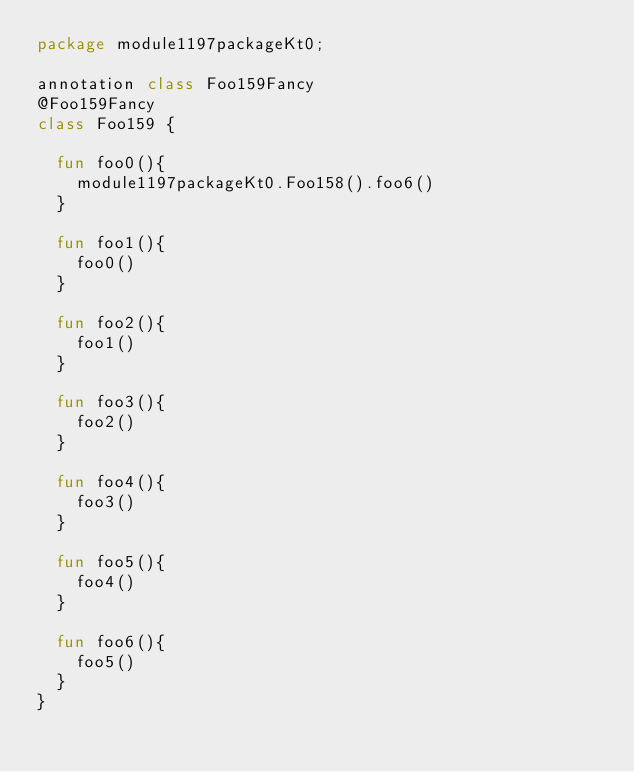<code> <loc_0><loc_0><loc_500><loc_500><_Kotlin_>package module1197packageKt0;

annotation class Foo159Fancy
@Foo159Fancy
class Foo159 {

  fun foo0(){
    module1197packageKt0.Foo158().foo6()
  }

  fun foo1(){
    foo0()
  }

  fun foo2(){
    foo1()
  }

  fun foo3(){
    foo2()
  }

  fun foo4(){
    foo3()
  }

  fun foo5(){
    foo4()
  }

  fun foo6(){
    foo5()
  }
}</code> 